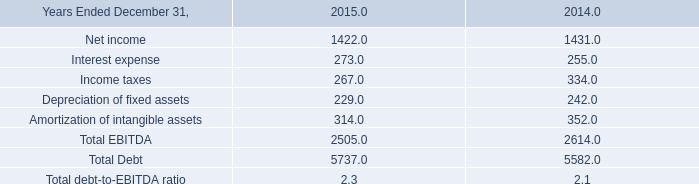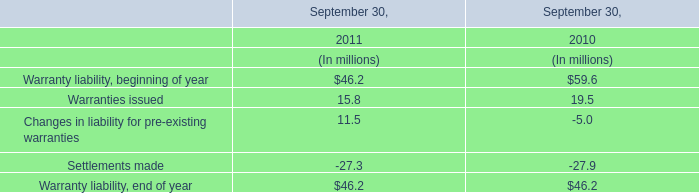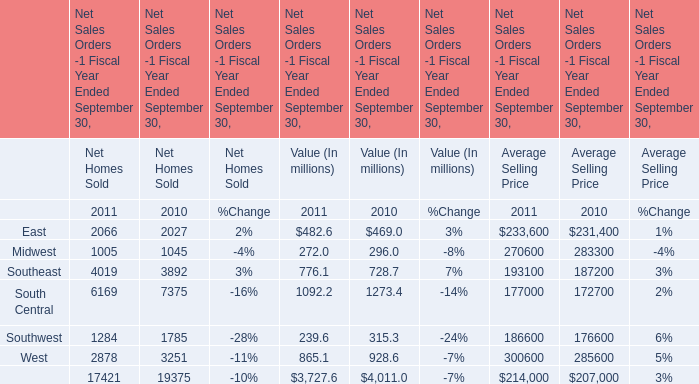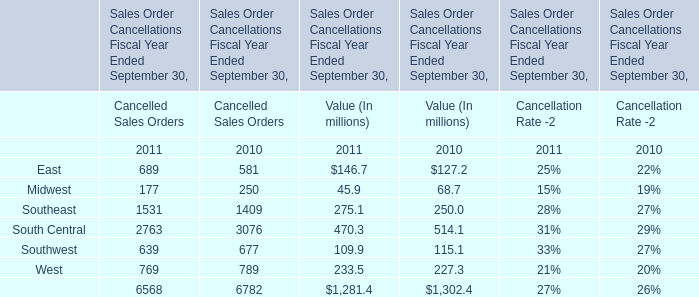In the year with largest amount of East for Cancelled Sales Orders, what's the increasing rate of East for Cancelled Sales Orders? 
Computations: ((689 - 581) / 581)
Answer: 0.18589. 